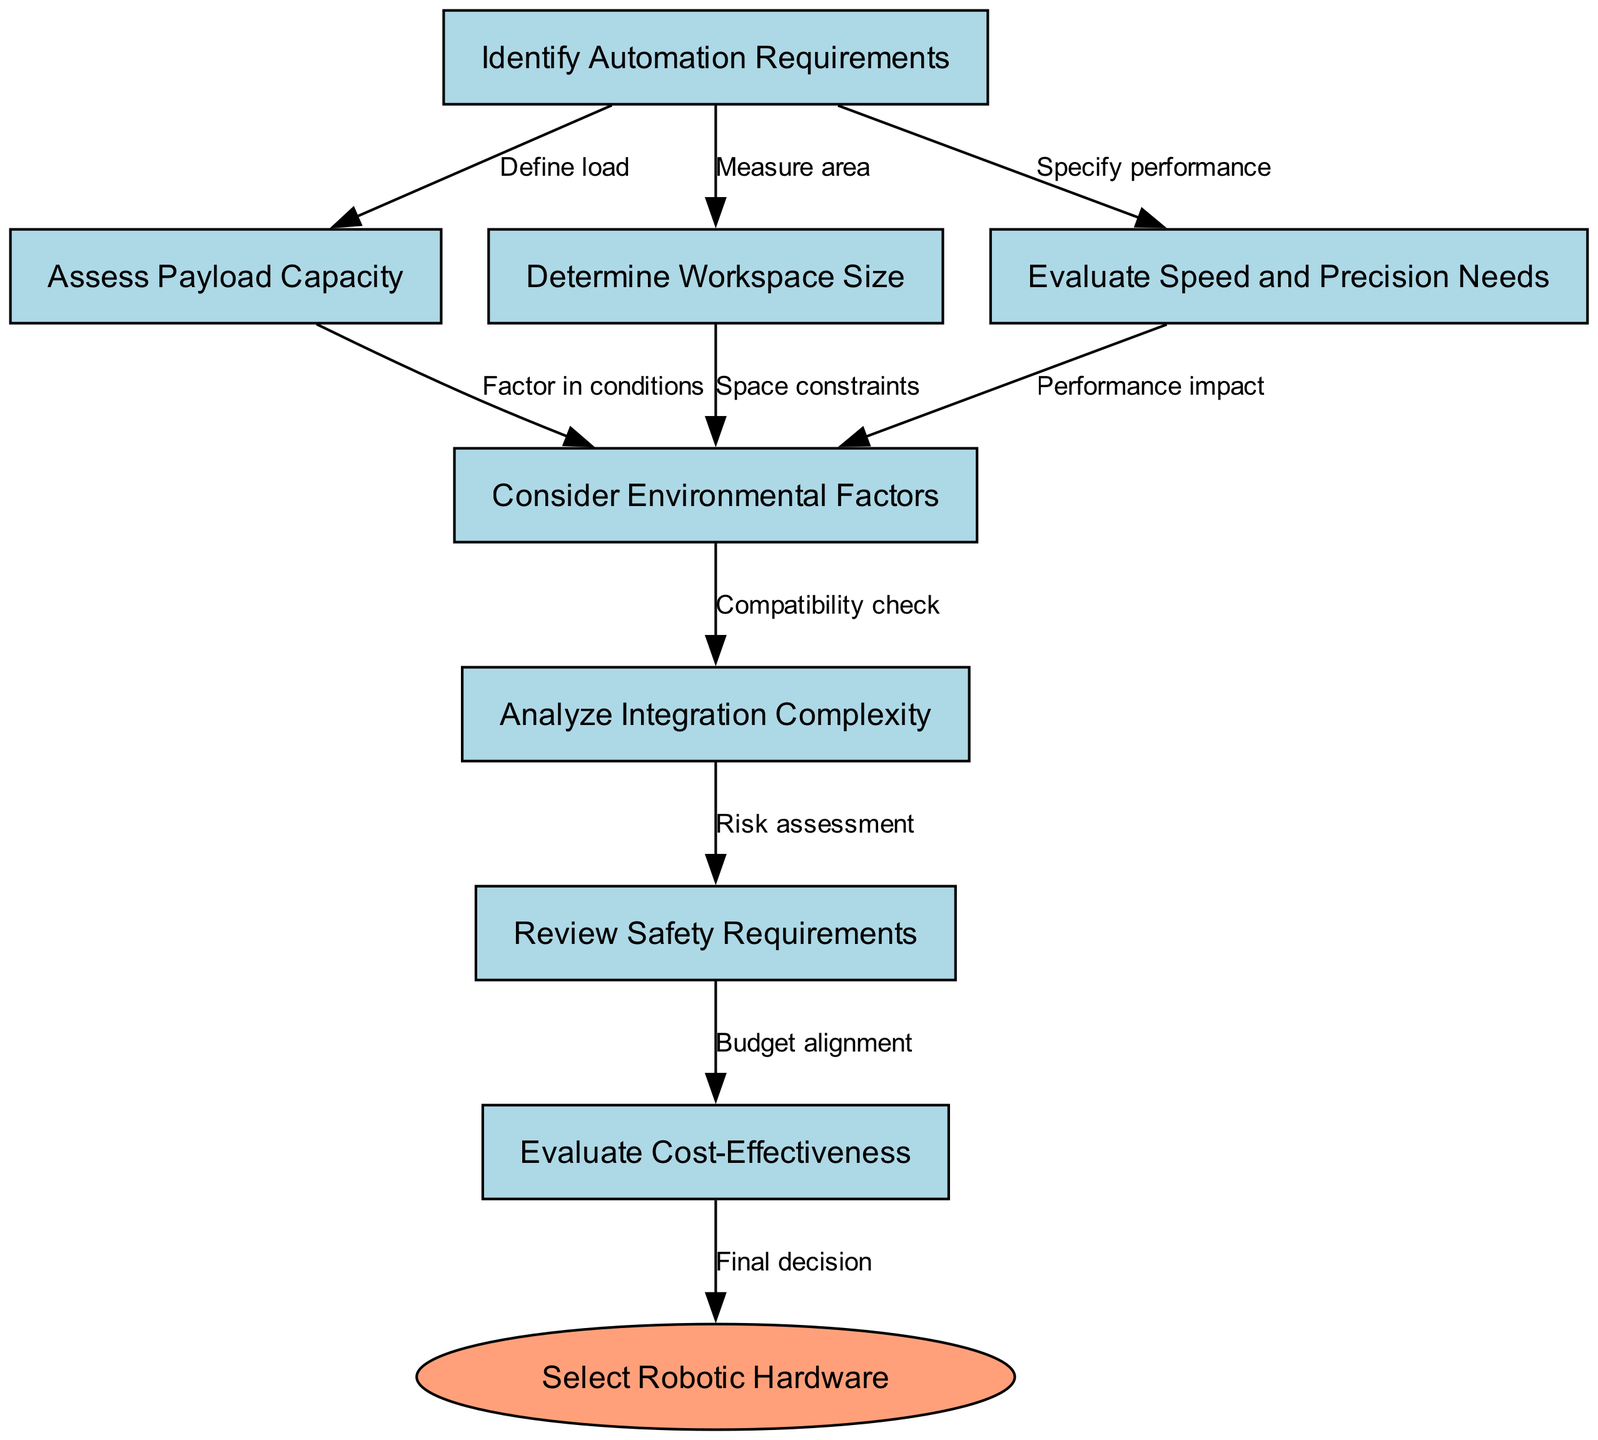What is the starting point of the flowchart? The flowchart begins at the node labeled "Identify Automation Requirements", which is indicated as the starting point in the diagram.
Answer: Identify Automation Requirements How many nodes are in the diagram? By counting all unique elements in the flowchart, there are a total of 8 nodes listed.
Answer: 8 What is the last step before selecting robotic hardware? The step before "Select Robotic Hardware" is "Evaluate Cost-Effectiveness", which directly leads to the final decision in the process.
Answer: Evaluate Cost-Effectiveness What label connects "Assess Payload Capacity" to "Consider Environmental Factors"? The label on the edge between these two nodes is "Factor in conditions", indicating the reasoning behind considering environmental factors based on the payload capabilities.
Answer: Factor in conditions What node evaluates safety requirements? The flowchart clearly shows "Review Safety Requirements" as the node dedicated to analyzing the safety aspects related to the selected robotic hardware.
Answer: Review Safety Requirements Which node comes after assessing speed and precision needs? The diagram shows that following "Evaluate Speed and Precision Needs", the next step is "Consider Environmental Factors", illustrating the flow towards more complex evaluations.
Answer: Consider Environmental Factors How many edges lead from the "Identify Automation Requirements" node? There are three edges leading from "Identify Automation Requirements", which connect to the nodes: "Assess Payload Capacity", "Determine Workspace Size", and "Evaluate Speed and Precision Needs".
Answer: 3 Which node represents the final decision point? The end of the decision-making process is represented by the node "Select Robotic Hardware", signifying the culmination of the assessment steps.
Answer: Select Robotic Hardware What is the relationship between "Analyze Integration Complexity" and "Review Safety Requirements"? The relationship is defined by the label "Risk assessment", indicating that the complexity of integration impacts safety considerations in the selection process.
Answer: Risk assessment 